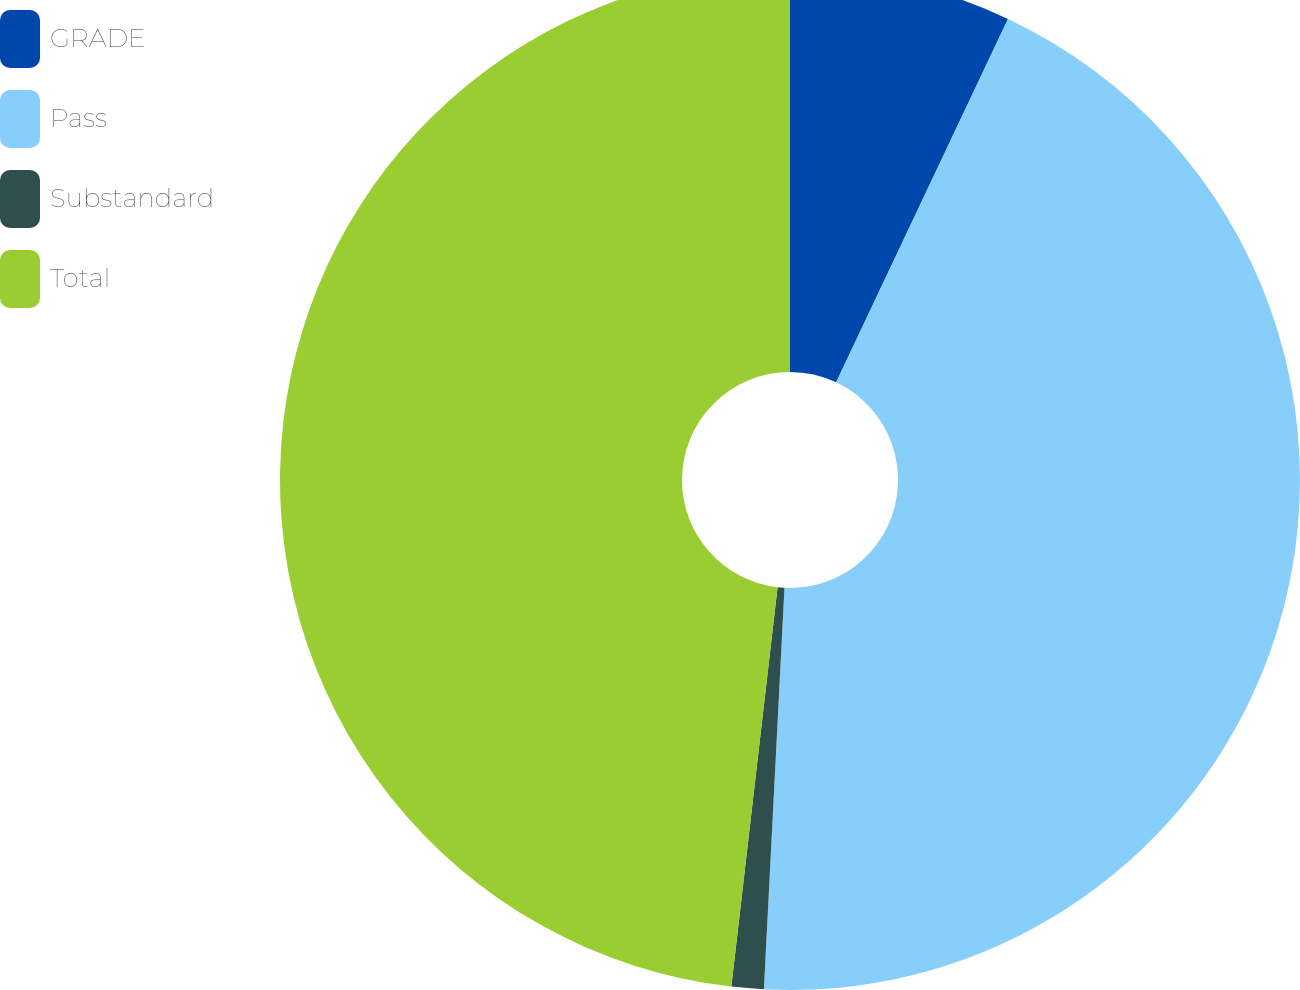Convert chart. <chart><loc_0><loc_0><loc_500><loc_500><pie_chart><fcel>GRADE<fcel>Pass<fcel>Substandard<fcel>Total<nl><fcel>7.03%<fcel>43.79%<fcel>1.02%<fcel>48.17%<nl></chart> 